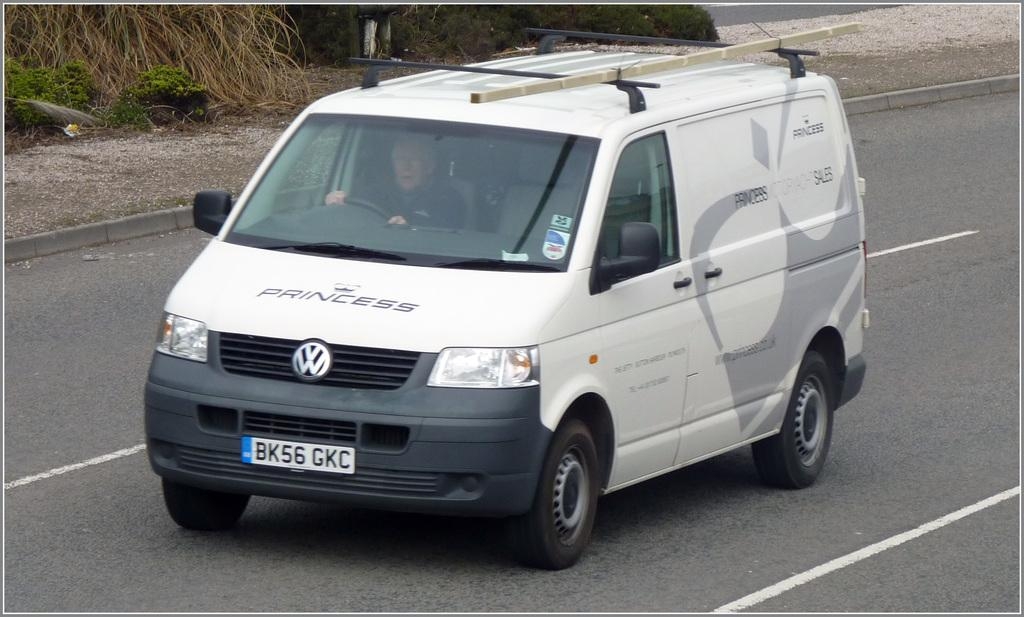Provide a one-sentence caption for the provided image. A white Volkswagon van with the word "Princess" written across the hood. 